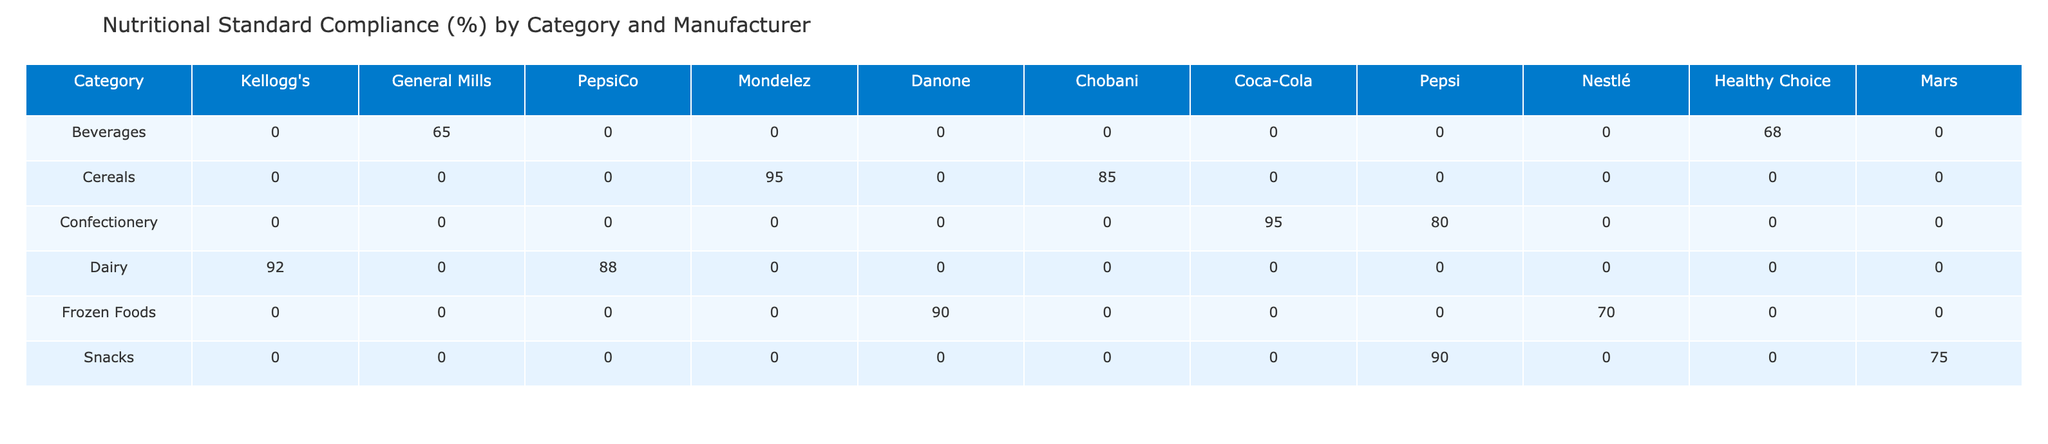What is the Nutritional Standard Compliance percentage for General Mills' Cheerios? From the table, under the "Cereals" category, the Nutritional Standard Compliance percentage for General Mills' Cheerios is listed as 95%.
Answer: 95% Which manufacturer has the lowest Compliance percentage in the Snacks category? In the Snacks category, the Compliance percentages are 75% for PepsiCo's Lays Classic and 90% for Mondelez's Oreos. Therefore, PepsiCo has the lowest Compliance percentage at 75%.
Answer: PepsiCo What is the average Nutritional Standard Compliance percentage across all manufacturers in the Dairy category? For the Dairy category, Danone's Oikos Greek Yogurt has an 88% compliance, and Chobani's Greek Yogurt has a 92% compliance. The average is calculated as (88 + 92) / 2 = 90%.
Answer: 90% Are all confectionery products compliant with Nutritional Standards above 80%? Looking at the Confectionery category, Mars' Wrigley's Extra Gum is 95% compliant, while Mondelez's Ritz Crackers have an 80% compliance. Both are above 80%, so the statement is correct.
Answer: Yes What is the difference in compliance between the highest and lowest compliant frozen food products? In the Frozen Foods category, Healthy Choice Meals have a compliance percentage of 90%, while Nestlé's Banquet Frozen Meals have 70%. The difference is 90% - 70% = 20%.
Answer: 20% Which beverage has the highest sodium content per serving? The sodium content per serving for Coca-Cola Classic is 45 mg, and for Pepsi Cola, it is 30 mg. Therefore, Coca-Cola Classic has the highest sodium content at 45 mg.
Answer: Coca-Cola Classic Is the average calorie count per serving higher for snacks or frozen foods? For Snacks, Lays Classic has 160 calories, and Oreos also have 160 calories, averaging 160 calories. In Frozen Foods, Banquet Frozen Meals have 270 calories, while Healthy Choice Meals have 220 calories, averaging 245 calories. Thus, the average for Frozen Foods is higher than for Snacks.
Answer: Frozen Foods Which product has the highest sugar content per serving, and what is that amount? Among the listed products, Coca-Cola Classic contains 39g of sugar per serving. This is higher than any other product.
Answer: 39g 